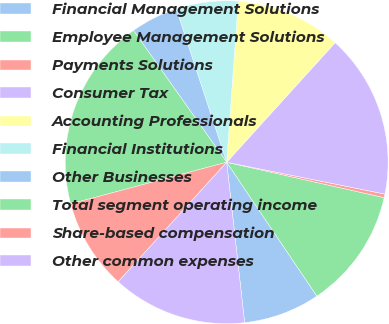<chart> <loc_0><loc_0><loc_500><loc_500><pie_chart><fcel>Financial Management Solutions<fcel>Employee Management Solutions<fcel>Payments Solutions<fcel>Consumer Tax<fcel>Accounting Professionals<fcel>Financial Institutions<fcel>Other Businesses<fcel>Total segment operating income<fcel>Share-based compensation<fcel>Other common expenses<nl><fcel>7.66%<fcel>12.04%<fcel>0.36%<fcel>16.43%<fcel>10.58%<fcel>6.2%<fcel>4.74%<fcel>19.35%<fcel>9.12%<fcel>13.5%<nl></chart> 